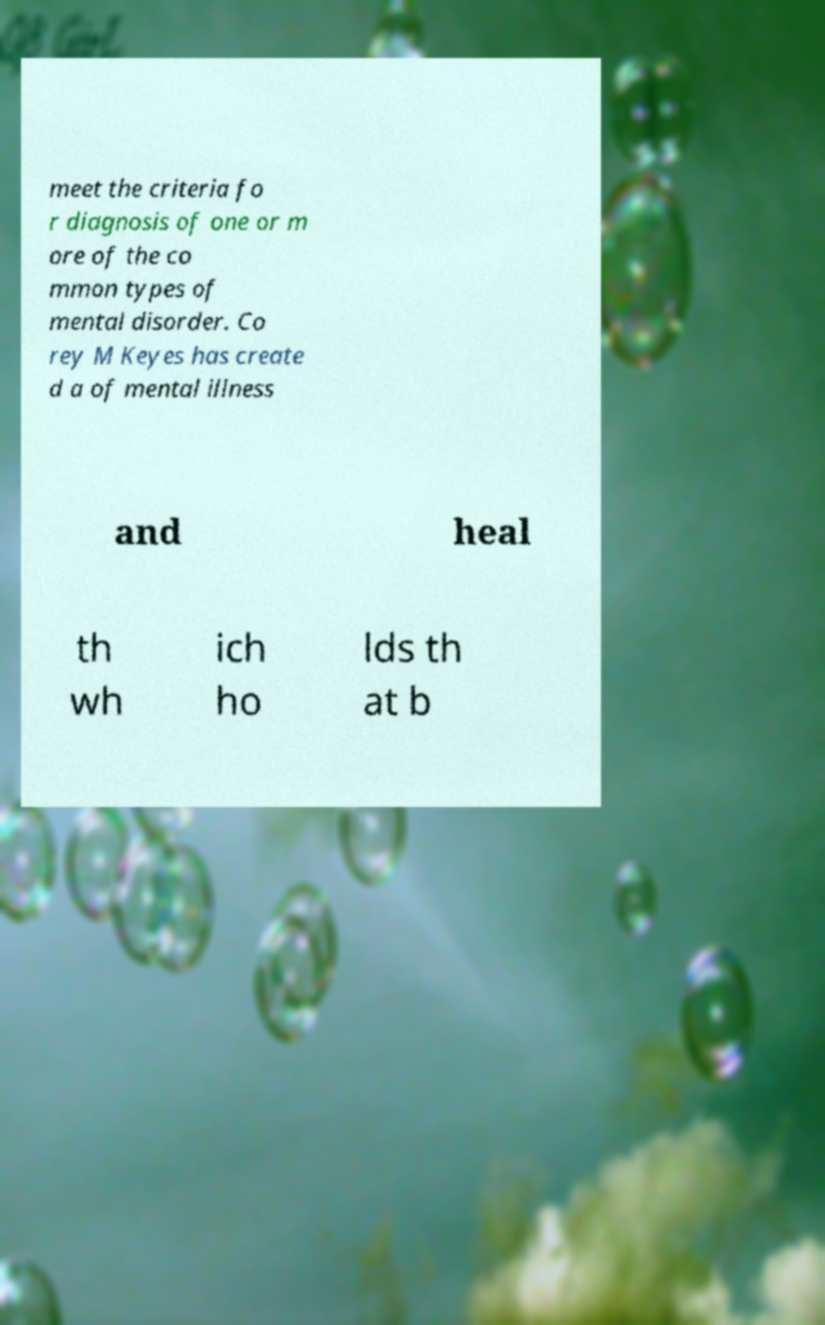Can you read and provide the text displayed in the image?This photo seems to have some interesting text. Can you extract and type it out for me? meet the criteria fo r diagnosis of one or m ore of the co mmon types of mental disorder. Co rey M Keyes has create d a of mental illness and heal th wh ich ho lds th at b 